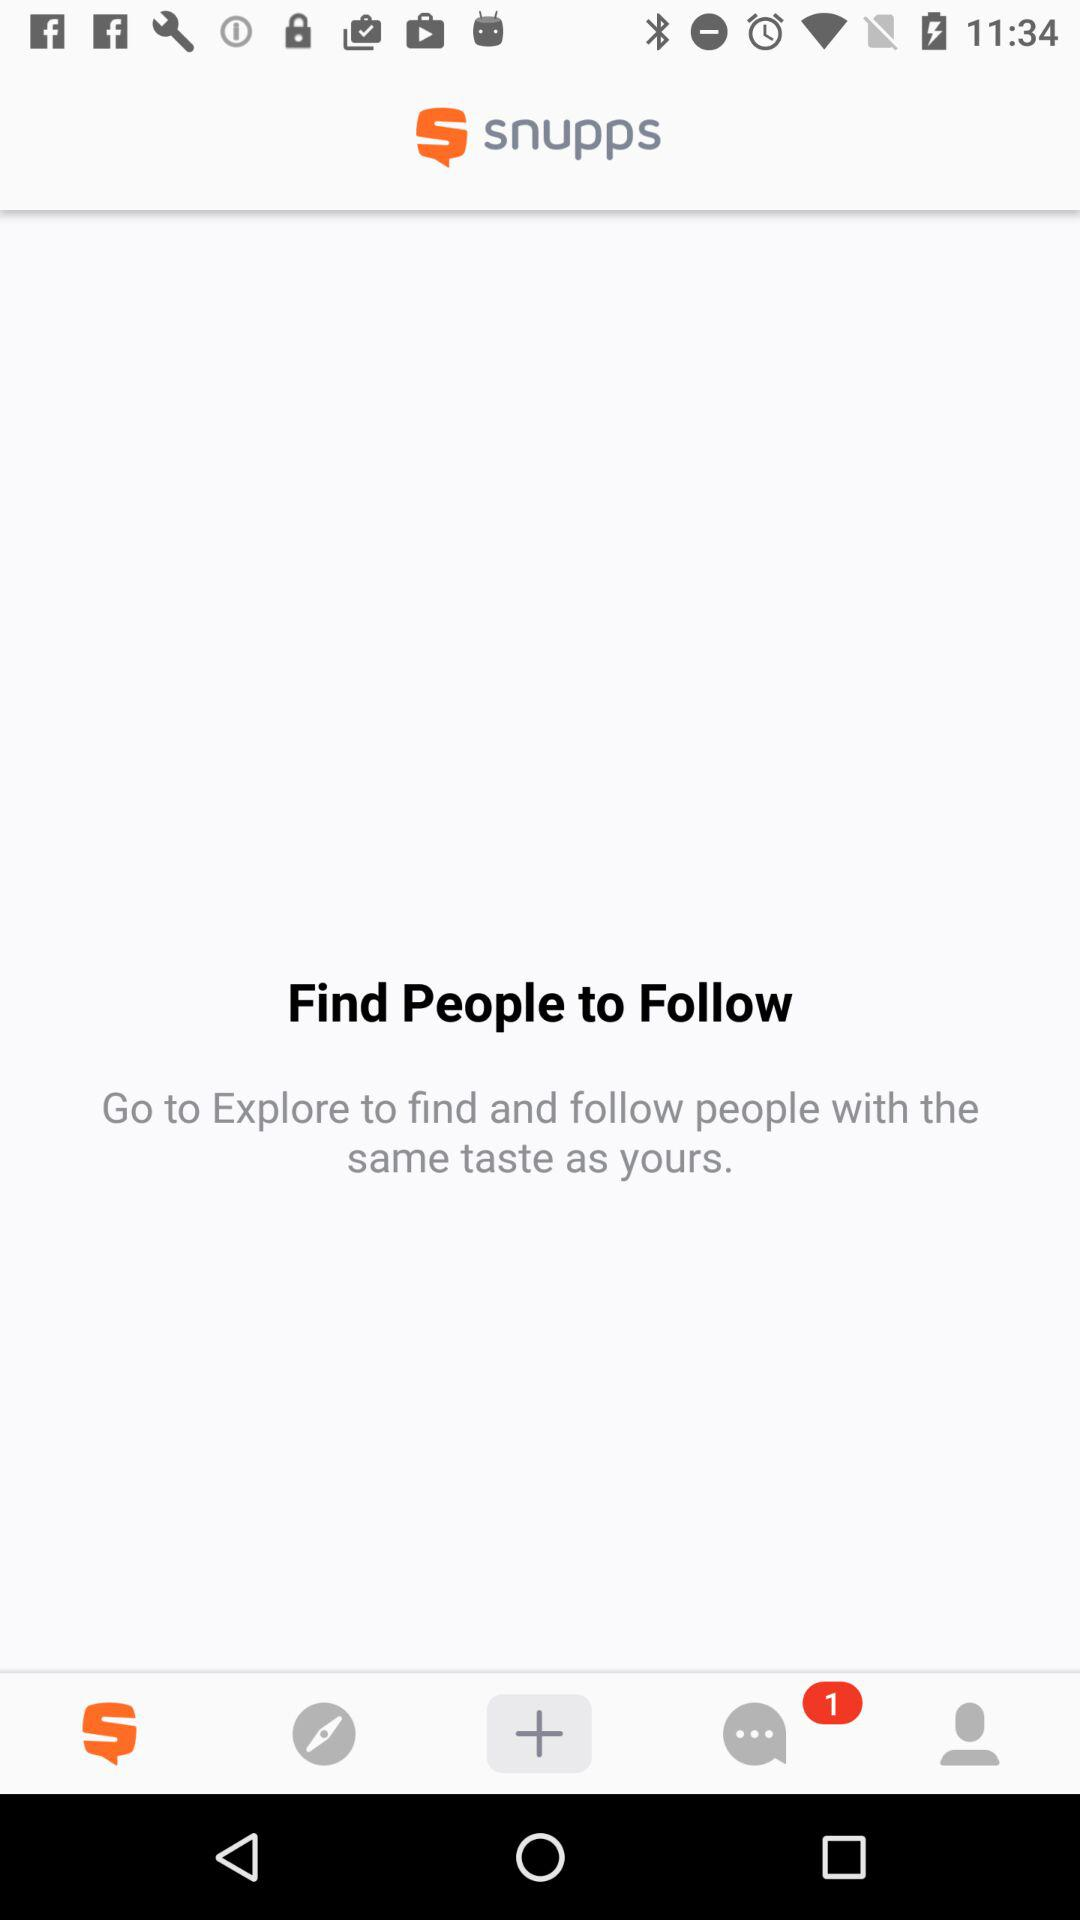What is the name of the application? The name of the application is "snupps". 